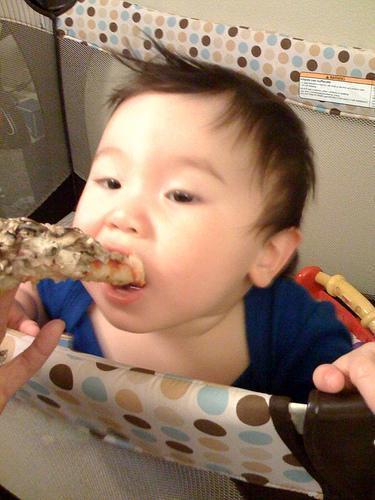How many pizzas are there?
Give a very brief answer. 1. 